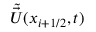<formula> <loc_0><loc_0><loc_500><loc_500>\tilde { \vec { U } } ( x _ { i + { 1 / 2 } } , t )</formula> 